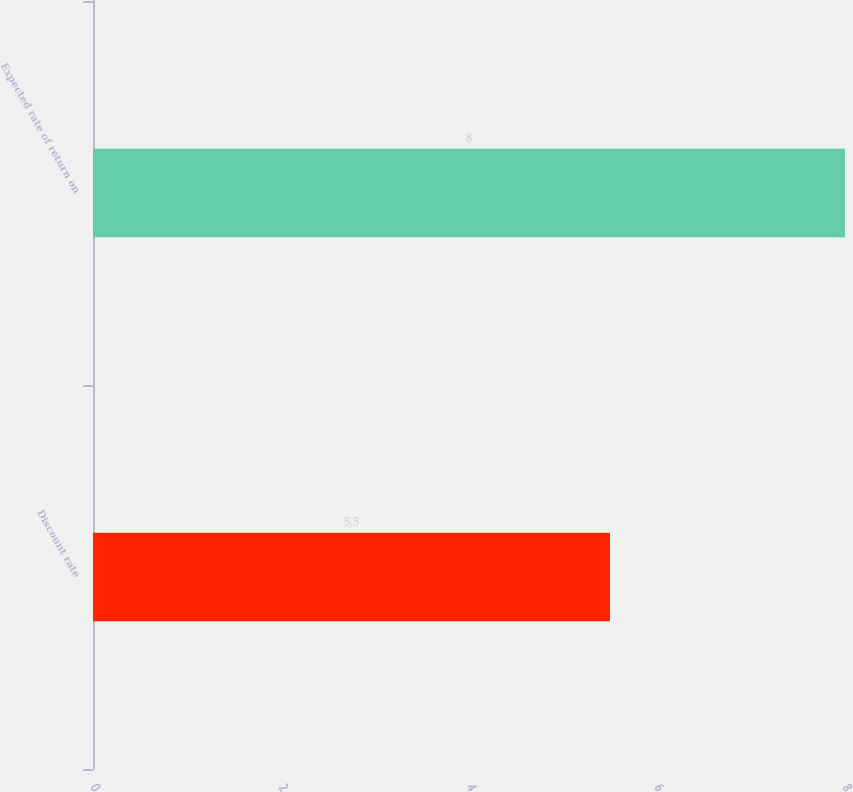Convert chart to OTSL. <chart><loc_0><loc_0><loc_500><loc_500><bar_chart><fcel>Discount rate<fcel>Expected rate of return on<nl><fcel>5.5<fcel>8<nl></chart> 